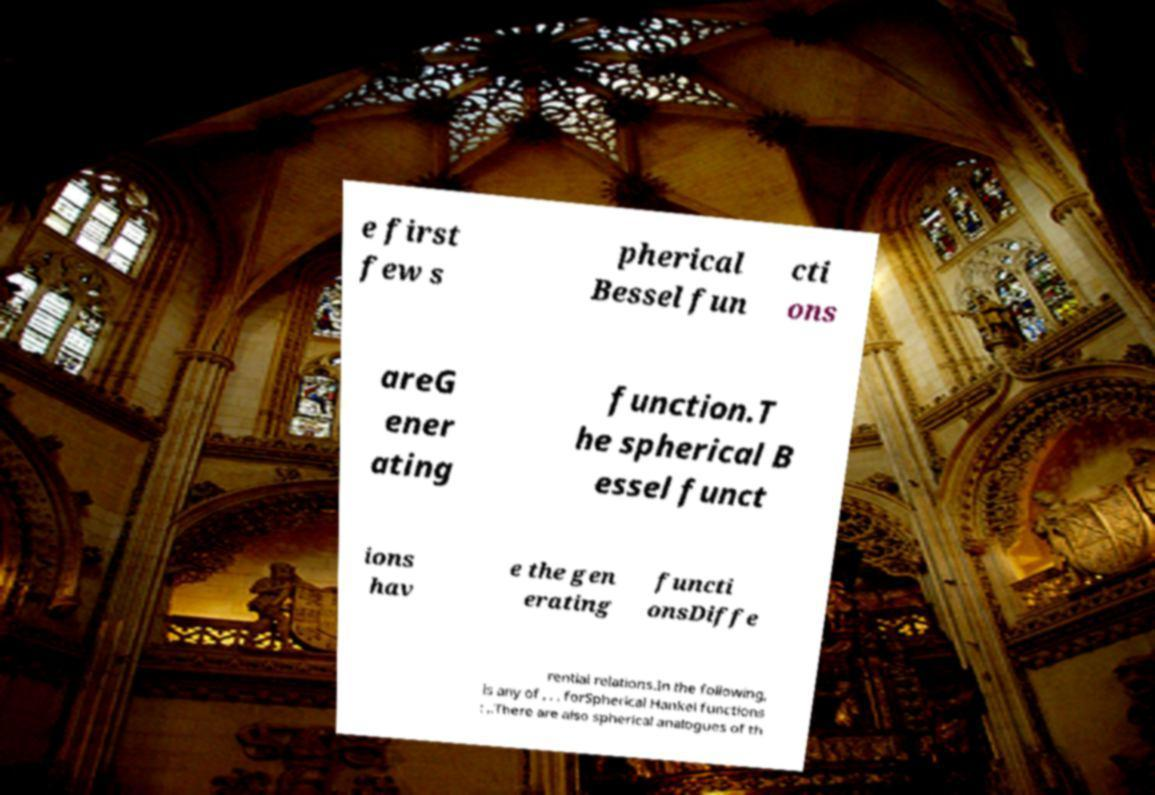Could you extract and type out the text from this image? e first few s pherical Bessel fun cti ons areG ener ating function.T he spherical B essel funct ions hav e the gen erating functi onsDiffe rential relations.In the following, is any of , , , forSpherical Hankel functions : ,.There are also spherical analogues of th 